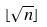Convert formula to latex. <formula><loc_0><loc_0><loc_500><loc_500>\lfloor \sqrt { n } \rfloor</formula> 